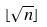Convert formula to latex. <formula><loc_0><loc_0><loc_500><loc_500>\lfloor \sqrt { n } \rfloor</formula> 